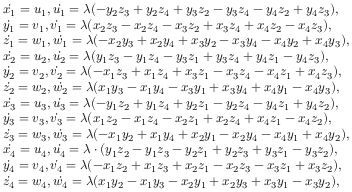Convert formula to latex. <formula><loc_0><loc_0><loc_500><loc_500>\begin{array} { r l } & { \dot { x _ { 1 } } = u _ { 1 } , \dot { u _ { 1 } } = \lambda ( - y _ { 2 } z _ { 3 } + y _ { 2 } z _ { 4 } + y _ { 3 } z _ { 2 } - y _ { 3 } z _ { 4 } - y _ { 4 } z _ { 2 } + y _ { 4 } z _ { 3 } ) , } \\ & { \dot { y _ { 1 } } = v _ { 1 } , \dot { v _ { 1 } } = \lambda ( x _ { 2 } z _ { 3 } - x _ { 2 } z _ { 4 } - x _ { 3 } z _ { 2 } + x _ { 3 } z _ { 4 } + x _ { 4 } z _ { 2 } - x _ { 4 } z _ { 3 } ) , } \\ & { \dot { z _ { 1 } } = w _ { 1 } , \dot { w _ { 1 } } = \lambda ( - x _ { 2 } y _ { 3 } + x _ { 2 } y _ { 4 } + x _ { 3 } y _ { 2 } - x _ { 3 } y _ { 4 } - x _ { 4 } y _ { 2 } + x _ { 4 } y _ { 3 } ) , } \\ & { \dot { x _ { 2 } } = u _ { 2 } , \dot { u _ { 2 } } = \lambda ( y _ { 1 } z _ { 3 } - y _ { 1 } z _ { 4 } - y _ { 3 } z _ { 1 } + y _ { 3 } z _ { 4 } + y _ { 4 } z _ { 1 } - y _ { 4 } z _ { 3 } ) , } \\ & { \dot { y _ { 2 } } = v _ { 2 } , \dot { v _ { 2 } } = \lambda ( - x _ { 1 } z _ { 3 } + x _ { 1 } z _ { 4 } + x _ { 3 } z _ { 1 } - x _ { 3 } z _ { 4 } - x _ { 4 } z _ { 1 } + x _ { 4 } z _ { 3 } ) , } \\ & { \dot { z _ { 2 } } = w _ { 2 } , \dot { w _ { 2 } } = \lambda ( x _ { 1 } y _ { 3 } - x _ { 1 } y _ { 4 } - x _ { 3 } y _ { 1 } + x _ { 3 } y _ { 4 } + x _ { 4 } y _ { 1 } - x _ { 4 } y _ { 3 } ) , } \\ & { \dot { x _ { 3 } } = u _ { 3 } , \dot { u _ { 3 } } = \lambda ( - y _ { 1 } z _ { 2 } + y _ { 1 } z _ { 4 } + y _ { 2 } z _ { 1 } - y _ { 2 } z _ { 4 } - y _ { 4 } z _ { 1 } + y _ { 4 } z _ { 2 } ) , } \\ & { \dot { y _ { 3 } } = v _ { 3 } , \dot { v _ { 3 } } = \lambda ( x _ { 1 } z _ { 2 } - x _ { 1 } z _ { 4 } - x _ { 2 } z _ { 1 } + x _ { 2 } z _ { 4 } + x _ { 4 } z _ { 1 } - x _ { 4 } z _ { 2 } ) , } \\ & { \dot { z _ { 3 } } = w _ { 3 } , \dot { w _ { 3 } } = \lambda ( - x _ { 1 } y _ { 2 } + x _ { 1 } y _ { 4 } + x _ { 2 } y _ { 1 } - x _ { 2 } y _ { 4 } - x _ { 4 } y _ { 1 } + x _ { 4 } y _ { 2 } ) , } \\ & { \dot { x _ { 4 } } = u _ { 4 } , \dot { u _ { 4 } } = \lambda \cdot ( y _ { 1 } z _ { 2 } - y _ { 1 } z _ { 3 } - y _ { 2 } z _ { 1 } + y _ { 2 } z _ { 3 } + y _ { 3 } z _ { 1 } - y _ { 3 } z _ { 2 } ) , } \\ & { \dot { y _ { 4 } } = v _ { 4 } , \dot { v _ { 4 } } = \lambda ( - x _ { 1 } z _ { 2 } + x _ { 1 } z _ { 3 } + x _ { 2 } z _ { 1 } - x _ { 2 } z _ { 3 } - x _ { 3 } z _ { 1 } + x _ { 3 } z _ { 2 } ) , } \\ & { \dot { z _ { 4 } } = w _ { 4 } , \dot { w _ { 4 } } = \lambda ( x _ { 1 } y _ { 2 } - x _ { 1 } y _ { 3 } - x _ { 2 } y _ { 1 } + x _ { 2 } y _ { 3 } + x _ { 3 } y _ { 1 } - x _ { 3 } y _ { 2 } ) , } \end{array}</formula> 